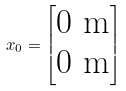Convert formula to latex. <formula><loc_0><loc_0><loc_500><loc_500>x _ { 0 } = \begin{bmatrix} 0 \text {\ m} \\ 0 \text {\ m} \end{bmatrix}</formula> 